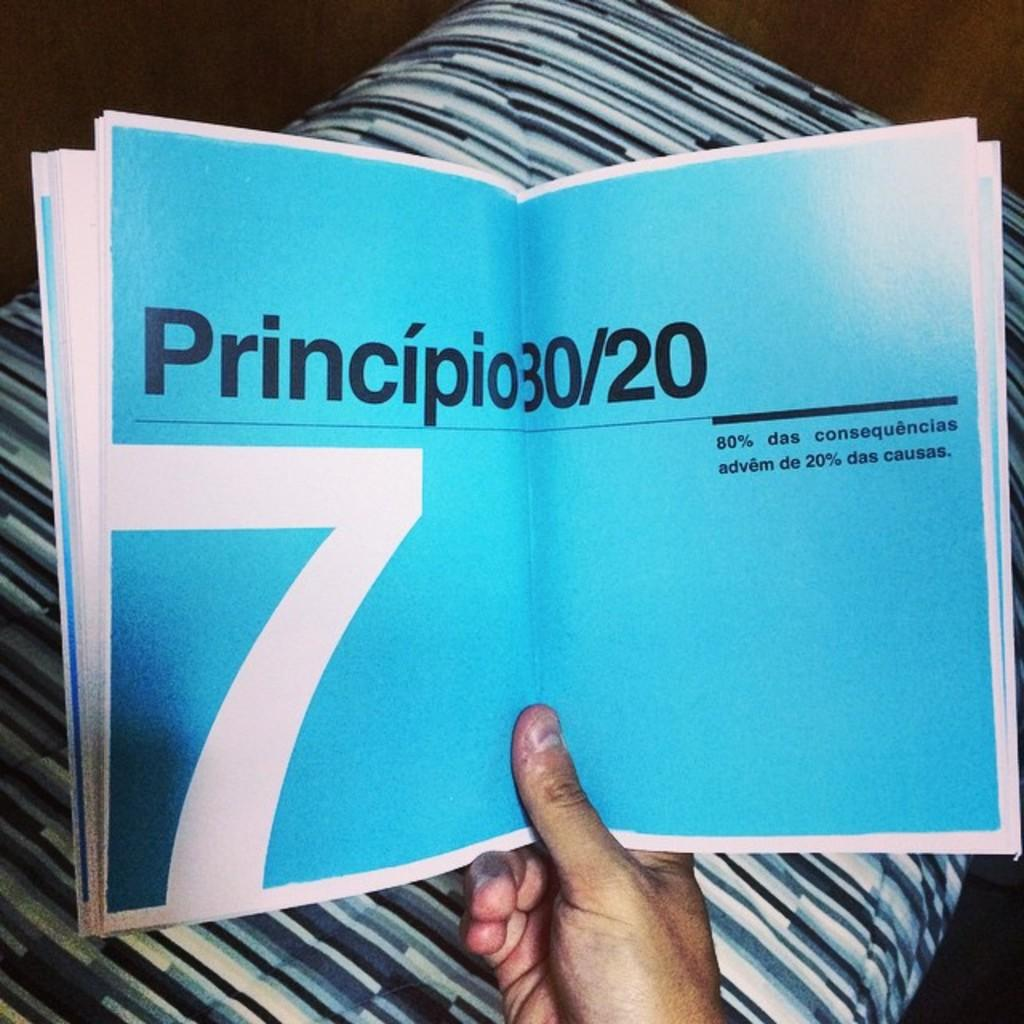Provide a one-sentence caption for the provided image. A book is opened to blue pages with black text that says "Principio 30/20.". 